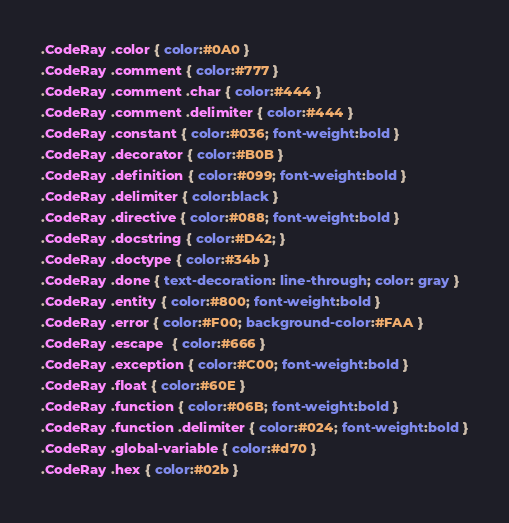<code> <loc_0><loc_0><loc_500><loc_500><_CSS_>.CodeRay .color { color:#0A0 }
.CodeRay .comment { color:#777 }
.CodeRay .comment .char { color:#444 }
.CodeRay .comment .delimiter { color:#444 }
.CodeRay .constant { color:#036; font-weight:bold }
.CodeRay .decorator { color:#B0B }
.CodeRay .definition { color:#099; font-weight:bold }
.CodeRay .delimiter { color:black }
.CodeRay .directive { color:#088; font-weight:bold }
.CodeRay .docstring { color:#D42; }
.CodeRay .doctype { color:#34b }
.CodeRay .done { text-decoration: line-through; color: gray }
.CodeRay .entity { color:#800; font-weight:bold }
.CodeRay .error { color:#F00; background-color:#FAA }
.CodeRay .escape  { color:#666 }
.CodeRay .exception { color:#C00; font-weight:bold }
.CodeRay .float { color:#60E }
.CodeRay .function { color:#06B; font-weight:bold }
.CodeRay .function .delimiter { color:#024; font-weight:bold }
.CodeRay .global-variable { color:#d70 }
.CodeRay .hex { color:#02b }</code> 